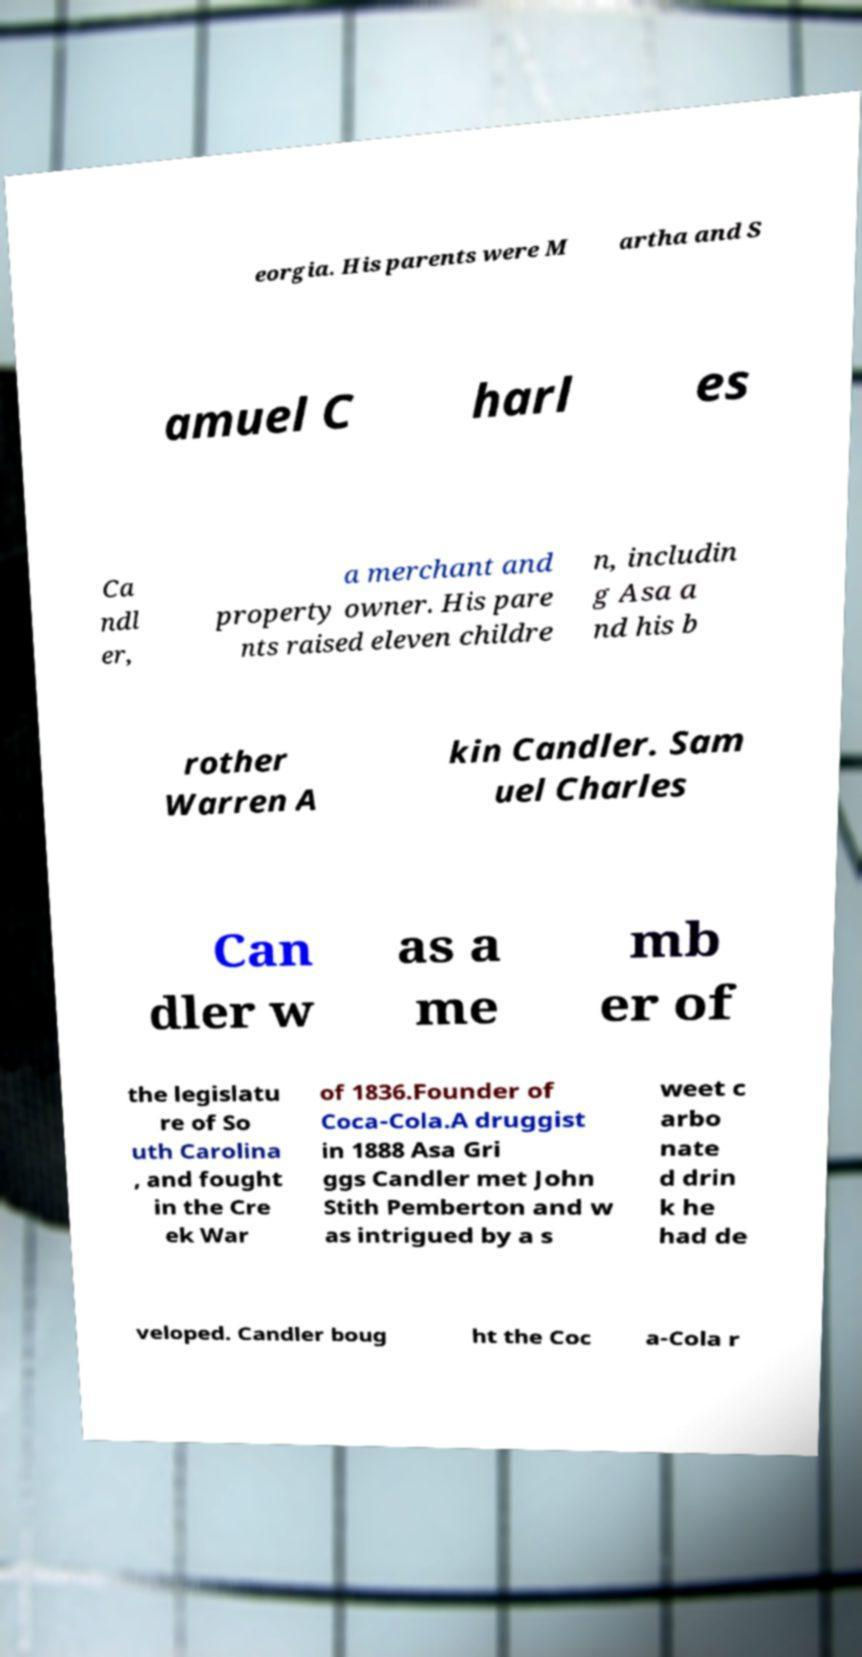Please read and relay the text visible in this image. What does it say? eorgia. His parents were M artha and S amuel C harl es Ca ndl er, a merchant and property owner. His pare nts raised eleven childre n, includin g Asa a nd his b rother Warren A kin Candler. Sam uel Charles Can dler w as a me mb er of the legislatu re of So uth Carolina , and fought in the Cre ek War of 1836.Founder of Coca-Cola.A druggist in 1888 Asa Gri ggs Candler met John Stith Pemberton and w as intrigued by a s weet c arbo nate d drin k he had de veloped. Candler boug ht the Coc a-Cola r 